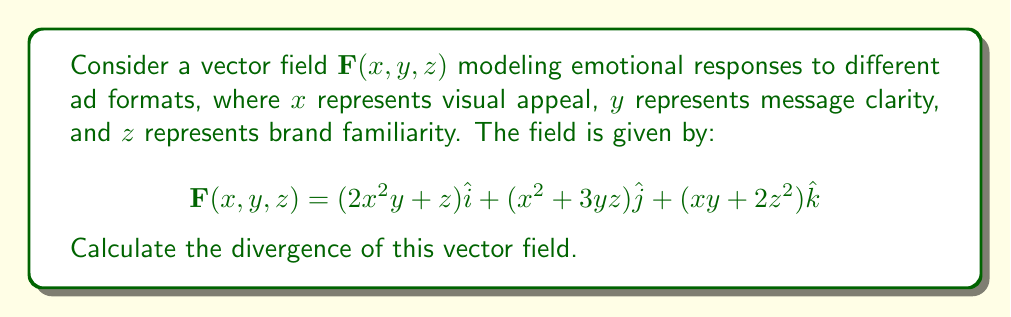Can you solve this math problem? To find the divergence of the vector field $\mathbf{F}(x, y, z)$, we need to calculate the sum of the partial derivatives of each component with respect to its corresponding variable. The divergence is given by:

$$\text{div}\mathbf{F} = \nabla \cdot \mathbf{F} = \frac{\partial F_x}{\partial x} + \frac{\partial F_y}{\partial y} + \frac{\partial F_z}{\partial z}$$

Let's calculate each partial derivative:

1. $\frac{\partial F_x}{\partial x}$:
   $F_x = 2x^2y + z$
   $\frac{\partial F_x}{\partial x} = 4xy$

2. $\frac{\partial F_y}{\partial y}$:
   $F_y = x^2 + 3yz$
   $\frac{\partial F_y}{\partial y} = 3z$

3. $\frac{\partial F_z}{\partial z}$:
   $F_z = xy + 2z^2$
   $\frac{\partial F_z}{\partial z} = 4z$

Now, we sum these partial derivatives:

$$\text{div}\mathbf{F} = \frac{\partial F_x}{\partial x} + \frac{\partial F_y}{\partial y} + \frac{\partial F_z}{\partial z}$$
$$\text{div}\mathbf{F} = 4xy + 3z + 4z$$
$$\text{div}\mathbf{F} = 4xy + 7z$$

This result represents the rate at which emotional response is "created" or "dissipated" at each point in the ad format space, considering visual appeal, message clarity, and brand familiarity.
Answer: $4xy + 7z$ 